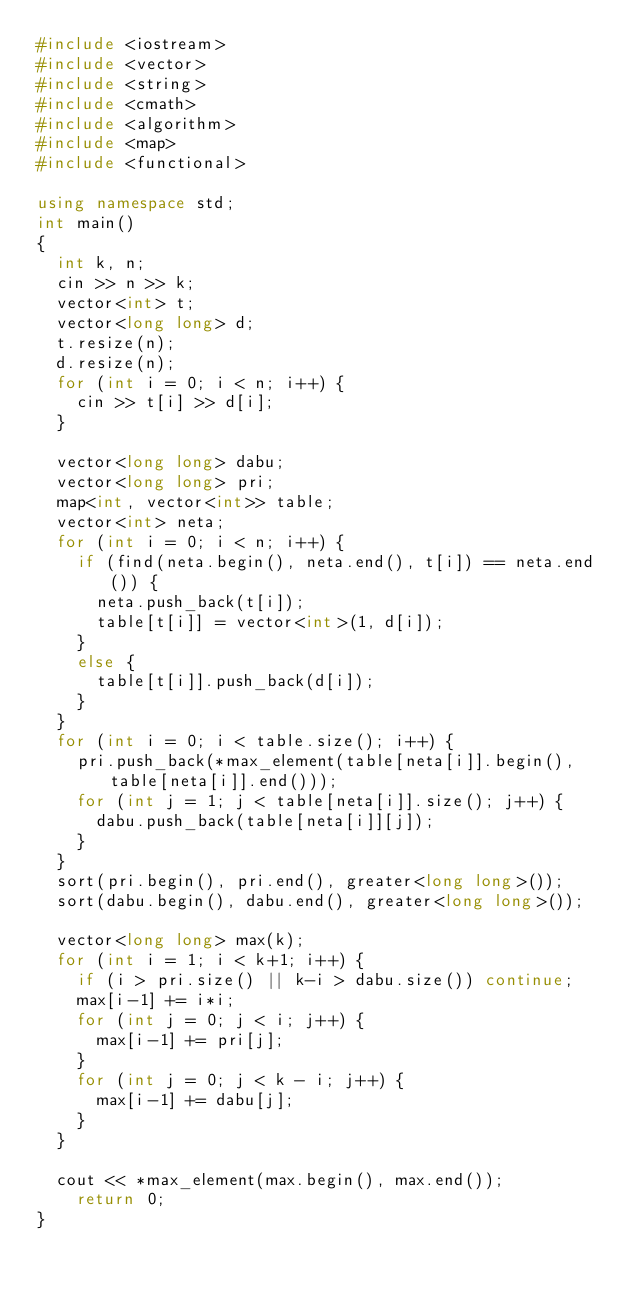Convert code to text. <code><loc_0><loc_0><loc_500><loc_500><_C++_>#include <iostream>
#include <vector>
#include <string>
#include <cmath>
#include <algorithm>
#include <map>
#include <functional>

using namespace std;
int main()
{
	int k, n;
	cin >> n >> k;
	vector<int> t;
	vector<long long> d;
	t.resize(n);
	d.resize(n);
	for (int i = 0; i < n; i++) {
		cin >> t[i] >> d[i];
	}

	vector<long long> dabu;
	vector<long long> pri;
	map<int, vector<int>> table;
	vector<int> neta;
	for (int i = 0; i < n; i++) {
		if (find(neta.begin(), neta.end(), t[i]) == neta.end()) {
			neta.push_back(t[i]);
			table[t[i]] = vector<int>(1, d[i]);
		}
		else {
			table[t[i]].push_back(d[i]);
		}
	}
	for (int i = 0; i < table.size(); i++) {
		pri.push_back(*max_element(table[neta[i]].begin(), table[neta[i]].end()));
		for (int j = 1; j < table[neta[i]].size(); j++) {
			dabu.push_back(table[neta[i]][j]);
		}
	}
	sort(pri.begin(), pri.end(), greater<long long>());
	sort(dabu.begin(), dabu.end(), greater<long long>());

	vector<long long> max(k);
	for (int i = 1; i < k+1; i++) {
		if (i > pri.size() || k-i > dabu.size()) continue;
		max[i-1] += i*i;
		for (int j = 0; j < i; j++) {
			max[i-1] += pri[j];
		}
		for (int j = 0; j < k - i; j++) {
			max[i-1] += dabu[j];
		}
	}

	cout << *max_element(max.begin(), max.end());
    return 0;
}

</code> 